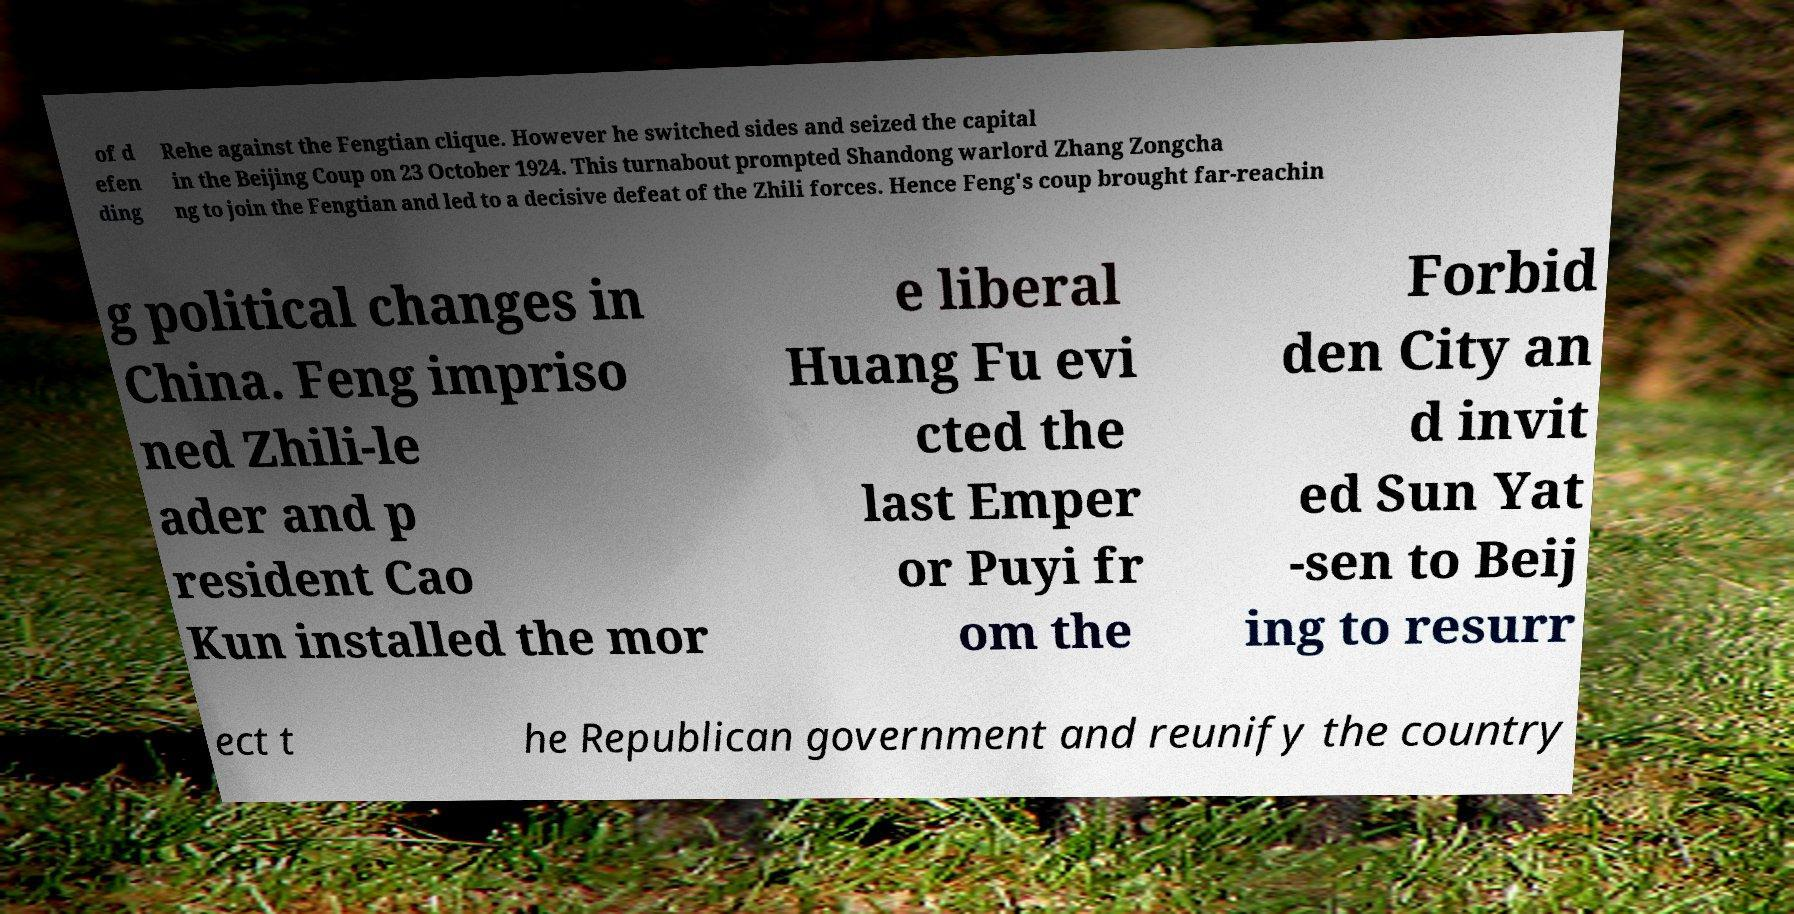I need the written content from this picture converted into text. Can you do that? of d efen ding Rehe against the Fengtian clique. However he switched sides and seized the capital in the Beijing Coup on 23 October 1924. This turnabout prompted Shandong warlord Zhang Zongcha ng to join the Fengtian and led to a decisive defeat of the Zhili forces. Hence Feng's coup brought far-reachin g political changes in China. Feng impriso ned Zhili-le ader and p resident Cao Kun installed the mor e liberal Huang Fu evi cted the last Emper or Puyi fr om the Forbid den City an d invit ed Sun Yat -sen to Beij ing to resurr ect t he Republican government and reunify the country 